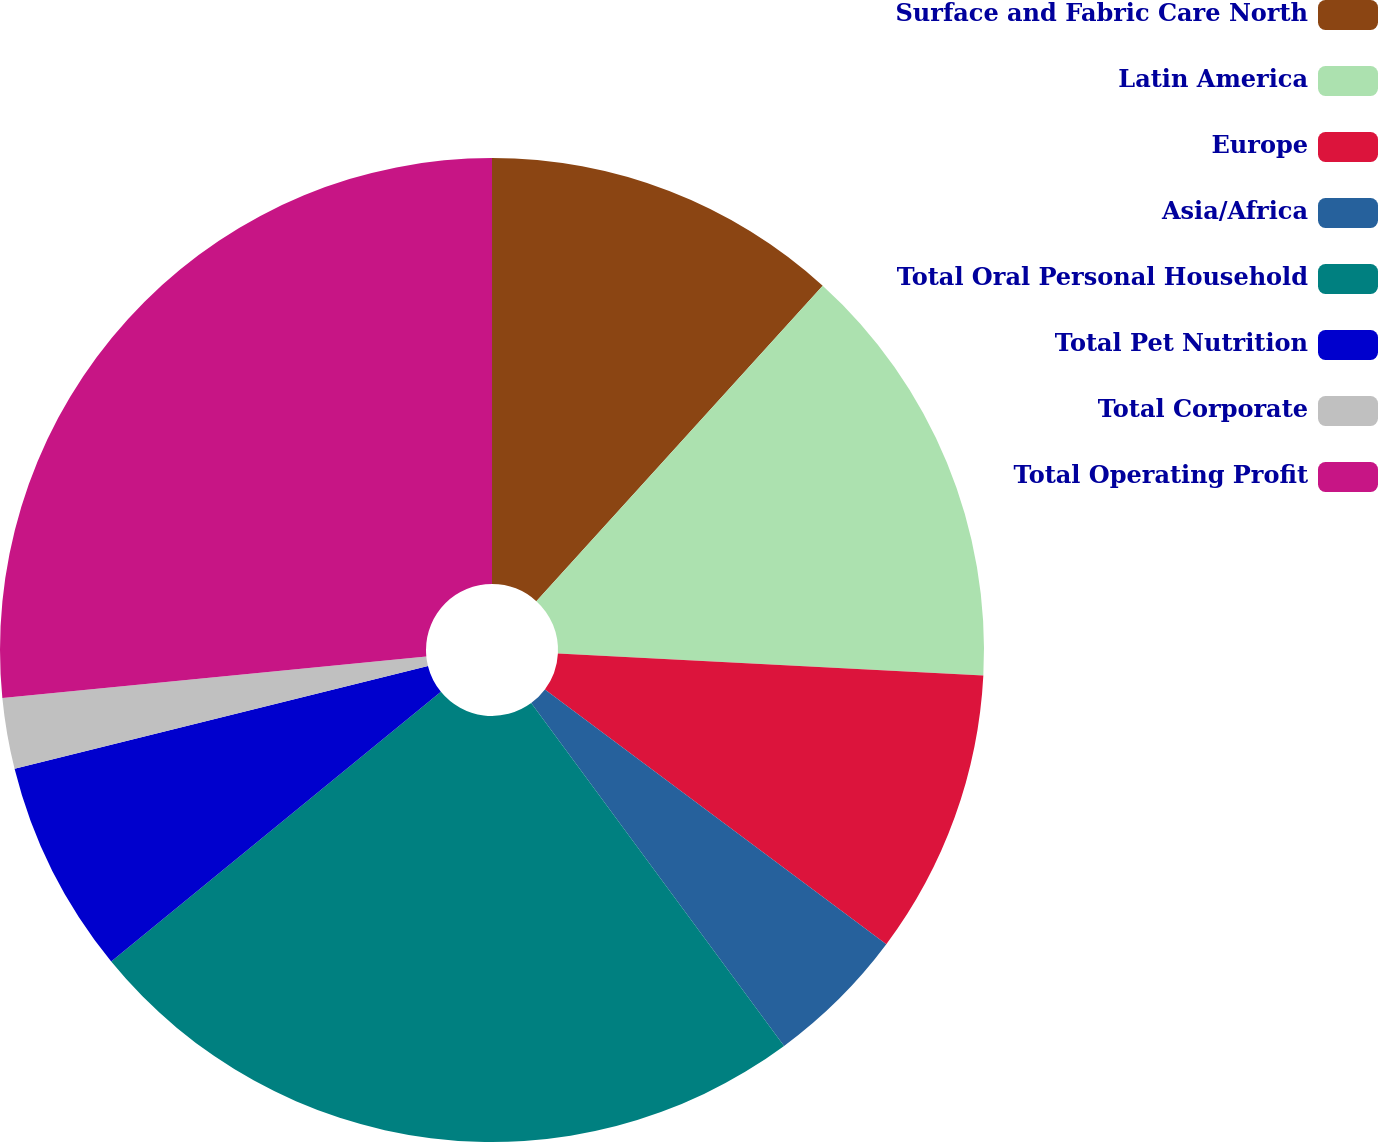<chart> <loc_0><loc_0><loc_500><loc_500><pie_chart><fcel>Surface and Fabric Care North<fcel>Latin America<fcel>Europe<fcel>Asia/Africa<fcel>Total Oral Personal Household<fcel>Total Pet Nutrition<fcel>Total Corporate<fcel>Total Operating Profit<nl><fcel>11.73%<fcel>14.09%<fcel>9.38%<fcel>4.68%<fcel>24.2%<fcel>7.03%<fcel>2.33%<fcel>26.55%<nl></chart> 